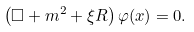<formula> <loc_0><loc_0><loc_500><loc_500>\left ( \Box + m ^ { 2 } + \xi R \right ) \varphi ( x ) = 0 .</formula> 